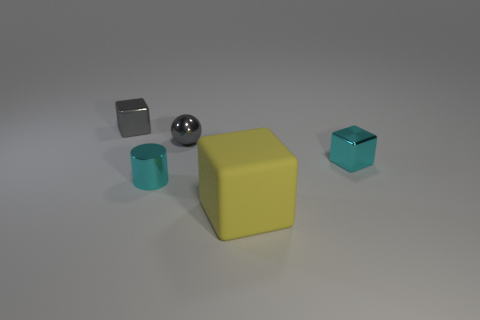How many objects are there and can you describe their shapes? There are five objects in the image. Starting from the left, there's a small, dark gray metal cube, followed by a shiny silver sphere. Next is a large, matte lemon cube, a teal cylindrical cup, and finally, a small teal cube with what appears to be a reflective surface. 